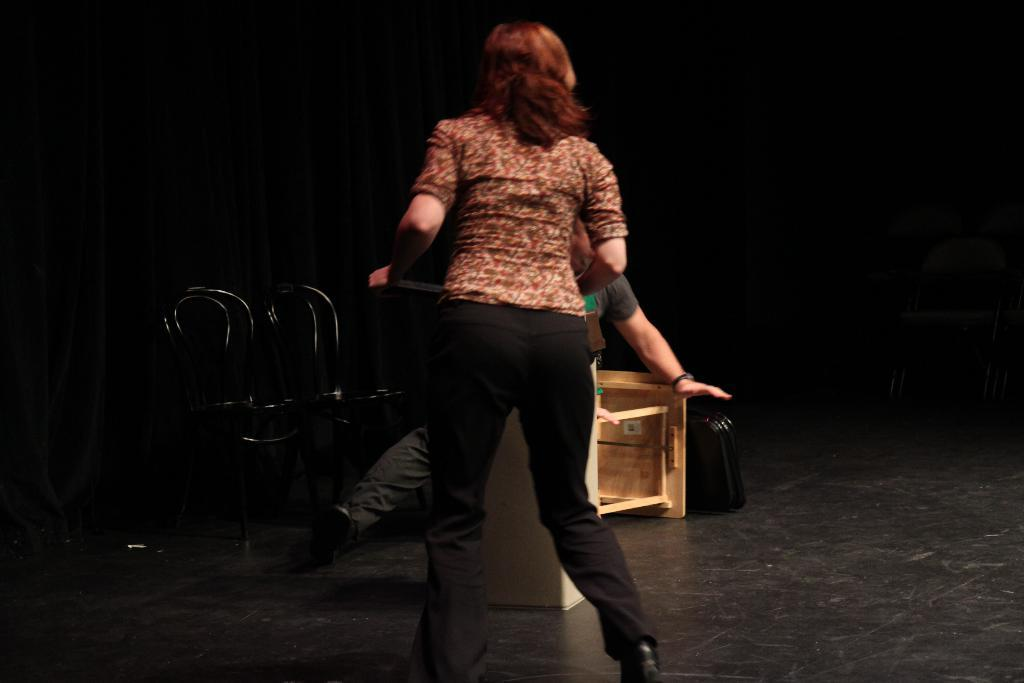How many people are in the image? There is a man and a woman in the image. What are the man and woman doing in the image? Both the man and woman are on the floor. What is the woman holding in the image? The woman is holding an object. What type of furniture is present in the image? There are chairs and a table in the image. Can you describe the object placed on a surface in the image? There is an object placed on a surface in the image, but the specific details are not provided. What type of farm animals can be seen in the image? There are no farm animals present in the image. How does the behavior of the man and woman in the image compare to that of things? The question is unclear and does not relate to the image, as it compares the behavior of people to that of inanimate objects. 